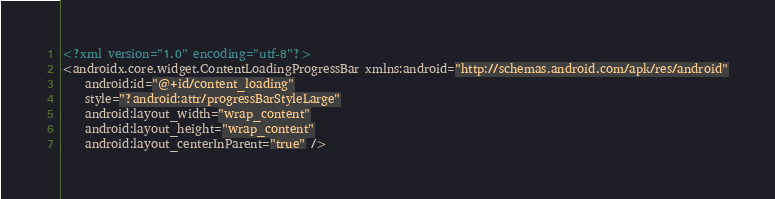<code> <loc_0><loc_0><loc_500><loc_500><_XML_><?xml version="1.0" encoding="utf-8"?>
<androidx.core.widget.ContentLoadingProgressBar xmlns:android="http://schemas.android.com/apk/res/android"
    android:id="@+id/content_loading"
    style="?android:attr/progressBarStyleLarge"
    android:layout_width="wrap_content"
    android:layout_height="wrap_content"
    android:layout_centerInParent="true" />
</code> 